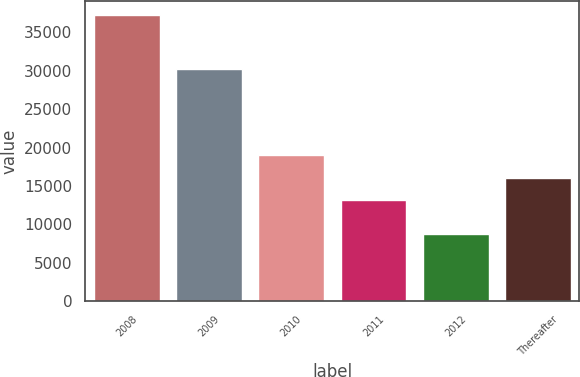Convert chart to OTSL. <chart><loc_0><loc_0><loc_500><loc_500><bar_chart><fcel>2008<fcel>2009<fcel>2010<fcel>2011<fcel>2012<fcel>Thereafter<nl><fcel>37253<fcel>30176<fcel>19069<fcel>13182<fcel>8800<fcel>16027.3<nl></chart> 